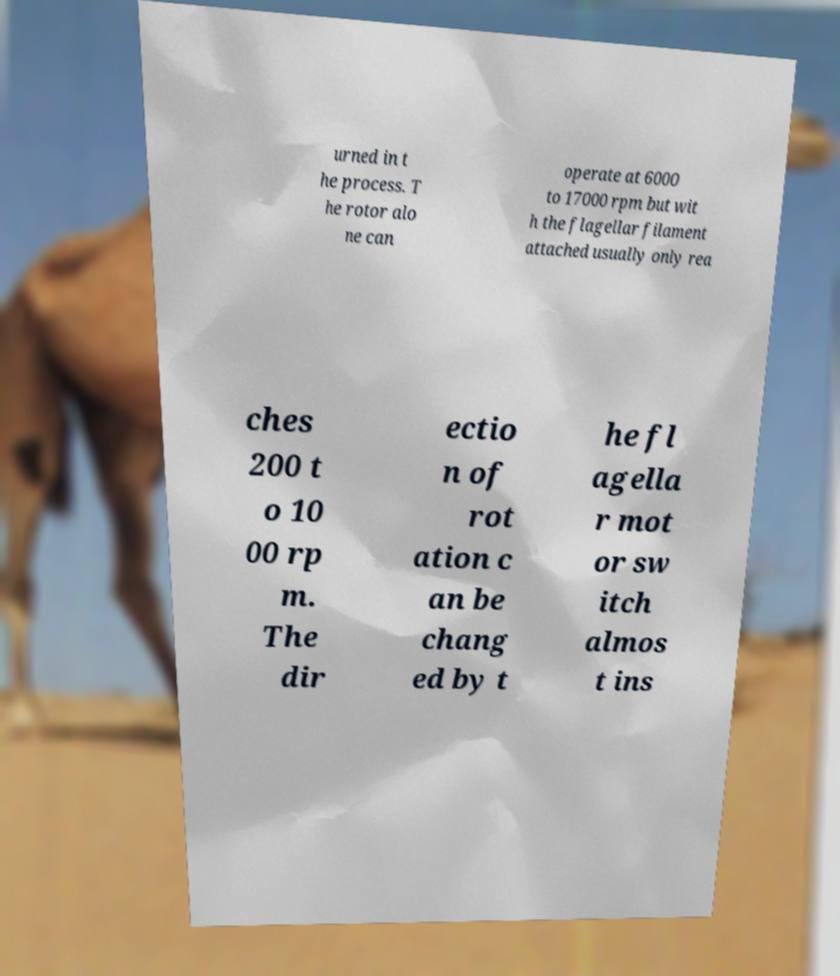Please read and relay the text visible in this image. What does it say? urned in t he process. T he rotor alo ne can operate at 6000 to 17000 rpm but wit h the flagellar filament attached usually only rea ches 200 t o 10 00 rp m. The dir ectio n of rot ation c an be chang ed by t he fl agella r mot or sw itch almos t ins 